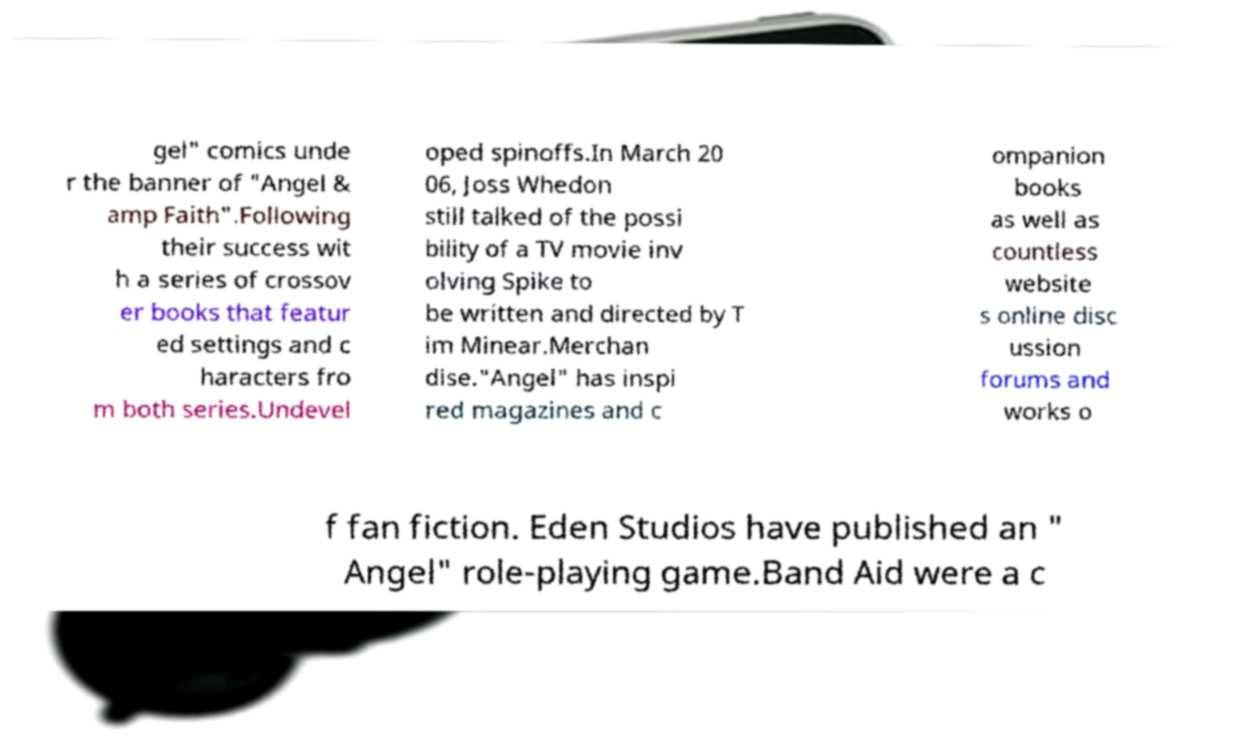There's text embedded in this image that I need extracted. Can you transcribe it verbatim? gel" comics unde r the banner of "Angel & amp Faith".Following their success wit h a series of crossov er books that featur ed settings and c haracters fro m both series.Undevel oped spinoffs.In March 20 06, Joss Whedon still talked of the possi bility of a TV movie inv olving Spike to be written and directed by T im Minear.Merchan dise."Angel" has inspi red magazines and c ompanion books as well as countless website s online disc ussion forums and works o f fan fiction. Eden Studios have published an " Angel" role-playing game.Band Aid were a c 